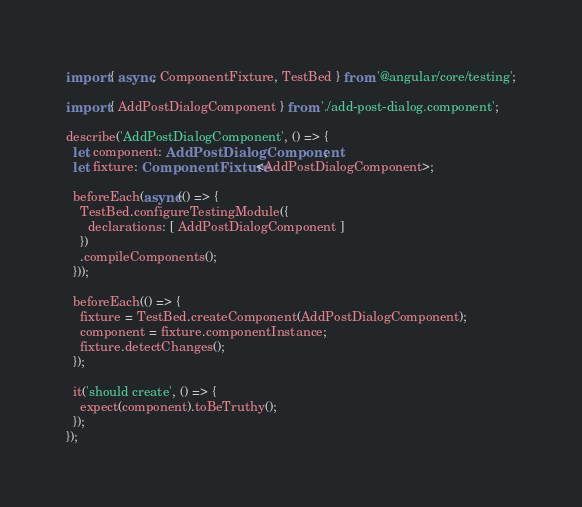Convert code to text. <code><loc_0><loc_0><loc_500><loc_500><_TypeScript_>import { async, ComponentFixture, TestBed } from '@angular/core/testing';

import { AddPostDialogComponent } from './add-post-dialog.component';

describe('AddPostDialogComponent', () => {
  let component: AddPostDialogComponent;
  let fixture: ComponentFixture<AddPostDialogComponent>;

  beforeEach(async(() => {
    TestBed.configureTestingModule({
      declarations: [ AddPostDialogComponent ]
    })
    .compileComponents();
  }));

  beforeEach(() => {
    fixture = TestBed.createComponent(AddPostDialogComponent);
    component = fixture.componentInstance;
    fixture.detectChanges();
  });

  it('should create', () => {
    expect(component).toBeTruthy();
  });
});
</code> 